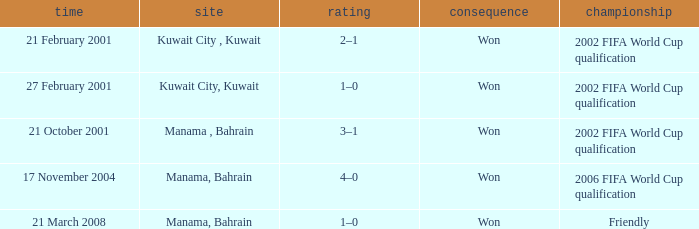On which date was the 2006 FIFA World Cup Qualification in Manama, Bahrain? 17 November 2004. Parse the table in full. {'header': ['time', 'site', 'rating', 'consequence', 'championship'], 'rows': [['21 February 2001', 'Kuwait City , Kuwait', '2–1', 'Won', '2002 FIFA World Cup qualification'], ['27 February 2001', 'Kuwait City, Kuwait', '1–0', 'Won', '2002 FIFA World Cup qualification'], ['21 October 2001', 'Manama , Bahrain', '3–1', 'Won', '2002 FIFA World Cup qualification'], ['17 November 2004', 'Manama, Bahrain', '4–0', 'Won', '2006 FIFA World Cup qualification'], ['21 March 2008', 'Manama, Bahrain', '1–0', 'Won', 'Friendly']]} 